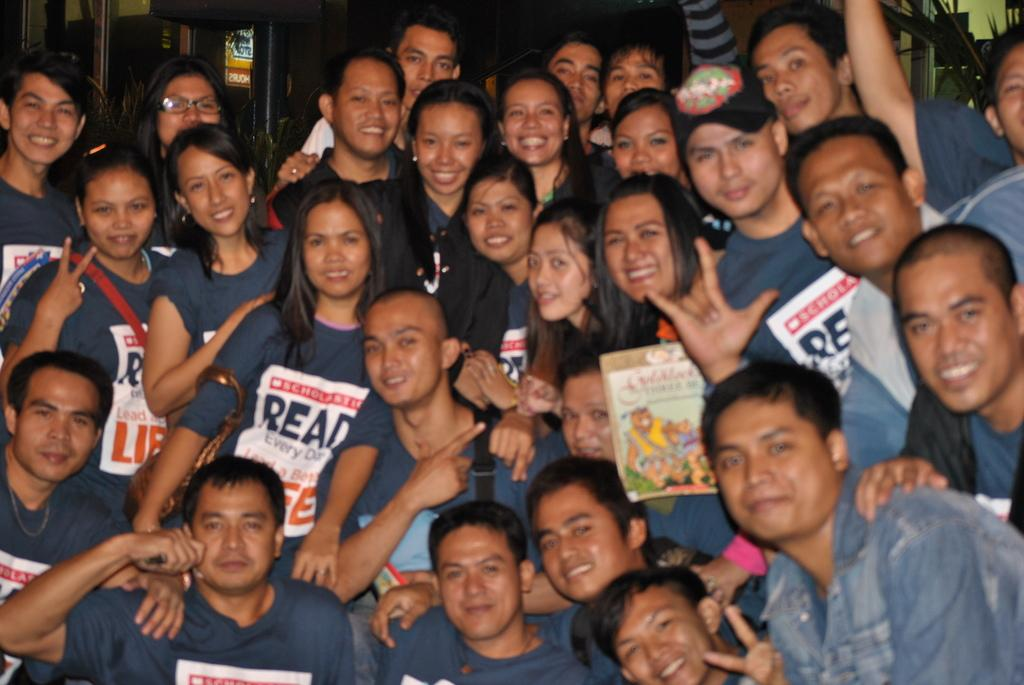What is the main subject of the image? The main subject of the image is a group of people. What can be observed about the clothing of the people in the image? The people are wearing blue color dress. Are there any specific details on the shirts of the people? Yes, there is something written on the shirts of the people. What can be seen in the background of the image? There are poles and a yellow-colored board in the background of the image. What type of car can be seen in the image? There is no car present in the image; it features a group of people wearing blue color dress with something written on their shirts, and there are poles and a yellow-colored board in the background. 